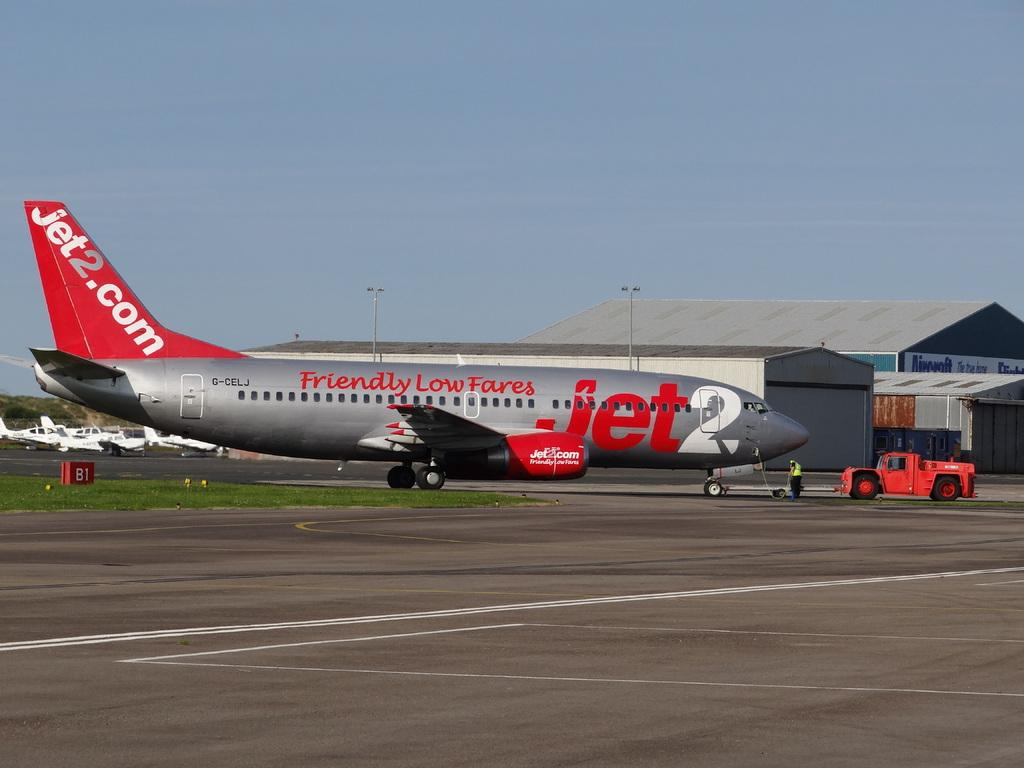<image>
Share a concise interpretation of the image provided. A grey and red jet on the runway that offers friendly low fares. 